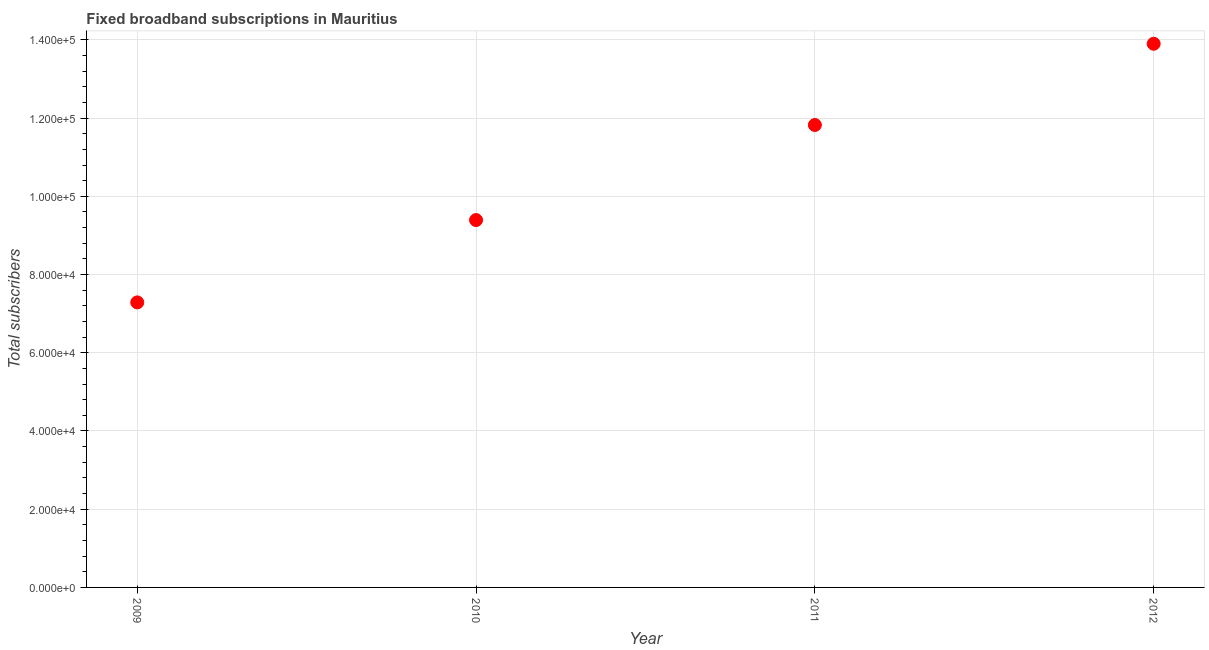What is the total number of fixed broadband subscriptions in 2010?
Ensure brevity in your answer.  9.39e+04. Across all years, what is the maximum total number of fixed broadband subscriptions?
Keep it short and to the point. 1.39e+05. Across all years, what is the minimum total number of fixed broadband subscriptions?
Offer a terse response. 7.29e+04. What is the sum of the total number of fixed broadband subscriptions?
Make the answer very short. 4.24e+05. What is the difference between the total number of fixed broadband subscriptions in 2009 and 2010?
Offer a very short reply. -2.10e+04. What is the average total number of fixed broadband subscriptions per year?
Make the answer very short. 1.06e+05. What is the median total number of fixed broadband subscriptions?
Keep it short and to the point. 1.06e+05. In how many years, is the total number of fixed broadband subscriptions greater than 104000 ?
Ensure brevity in your answer.  2. What is the ratio of the total number of fixed broadband subscriptions in 2009 to that in 2012?
Keep it short and to the point. 0.52. Is the difference between the total number of fixed broadband subscriptions in 2009 and 2010 greater than the difference between any two years?
Provide a short and direct response. No. What is the difference between the highest and the second highest total number of fixed broadband subscriptions?
Give a very brief answer. 2.08e+04. Is the sum of the total number of fixed broadband subscriptions in 2010 and 2012 greater than the maximum total number of fixed broadband subscriptions across all years?
Give a very brief answer. Yes. What is the difference between the highest and the lowest total number of fixed broadband subscriptions?
Provide a short and direct response. 6.61e+04. In how many years, is the total number of fixed broadband subscriptions greater than the average total number of fixed broadband subscriptions taken over all years?
Give a very brief answer. 2. Does the total number of fixed broadband subscriptions monotonically increase over the years?
Make the answer very short. Yes. How many dotlines are there?
Offer a terse response. 1. Are the values on the major ticks of Y-axis written in scientific E-notation?
Provide a succinct answer. Yes. What is the title of the graph?
Provide a short and direct response. Fixed broadband subscriptions in Mauritius. What is the label or title of the Y-axis?
Offer a very short reply. Total subscribers. What is the Total subscribers in 2009?
Offer a very short reply. 7.29e+04. What is the Total subscribers in 2010?
Keep it short and to the point. 9.39e+04. What is the Total subscribers in 2011?
Give a very brief answer. 1.18e+05. What is the Total subscribers in 2012?
Your answer should be very brief. 1.39e+05. What is the difference between the Total subscribers in 2009 and 2010?
Offer a terse response. -2.10e+04. What is the difference between the Total subscribers in 2009 and 2011?
Offer a very short reply. -4.54e+04. What is the difference between the Total subscribers in 2009 and 2012?
Your response must be concise. -6.61e+04. What is the difference between the Total subscribers in 2010 and 2011?
Make the answer very short. -2.43e+04. What is the difference between the Total subscribers in 2010 and 2012?
Offer a very short reply. -4.51e+04. What is the difference between the Total subscribers in 2011 and 2012?
Your answer should be compact. -2.08e+04. What is the ratio of the Total subscribers in 2009 to that in 2010?
Offer a very short reply. 0.78. What is the ratio of the Total subscribers in 2009 to that in 2011?
Provide a succinct answer. 0.62. What is the ratio of the Total subscribers in 2009 to that in 2012?
Keep it short and to the point. 0.52. What is the ratio of the Total subscribers in 2010 to that in 2011?
Provide a succinct answer. 0.79. What is the ratio of the Total subscribers in 2010 to that in 2012?
Make the answer very short. 0.68. What is the ratio of the Total subscribers in 2011 to that in 2012?
Make the answer very short. 0.85. 